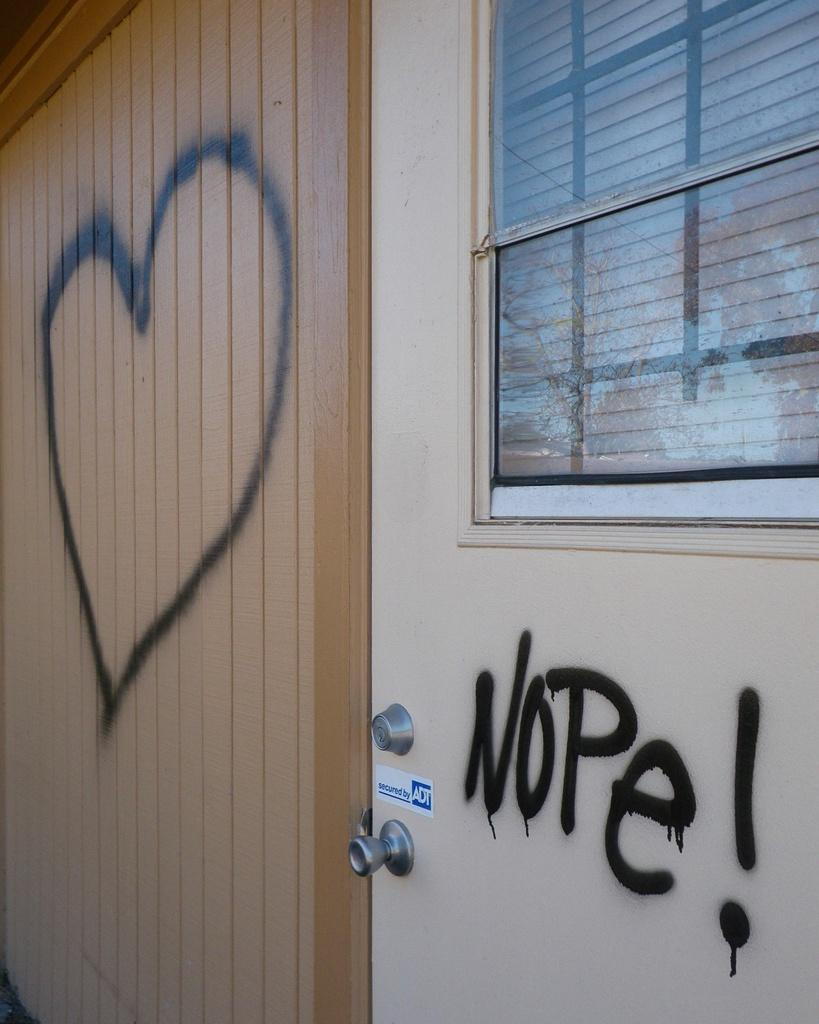What is the main architectural feature in the center of the image? There is a door in the center of the image. Can you identify any other architectural features in the image? Yes, there is a window in the image. What is on the left side of the image? There is a wall on the left side of the image. What is depicted on the wall? There is graffiti on the wall. What type of pail can be seen hanging from the door in the image? There is no pail present in the image, and it is not hanging from the door. 